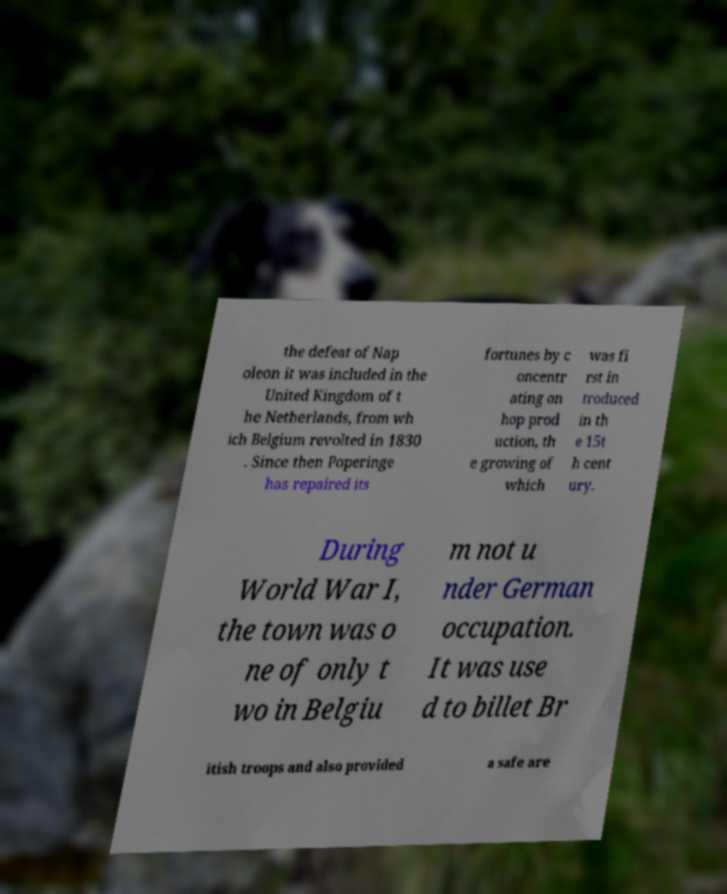Could you extract and type out the text from this image? the defeat of Nap oleon it was included in the United Kingdom of t he Netherlands, from wh ich Belgium revolted in 1830 . Since then Poperinge has repaired its fortunes by c oncentr ating on hop prod uction, th e growing of which was fi rst in troduced in th e 15t h cent ury. During World War I, the town was o ne of only t wo in Belgiu m not u nder German occupation. It was use d to billet Br itish troops and also provided a safe are 